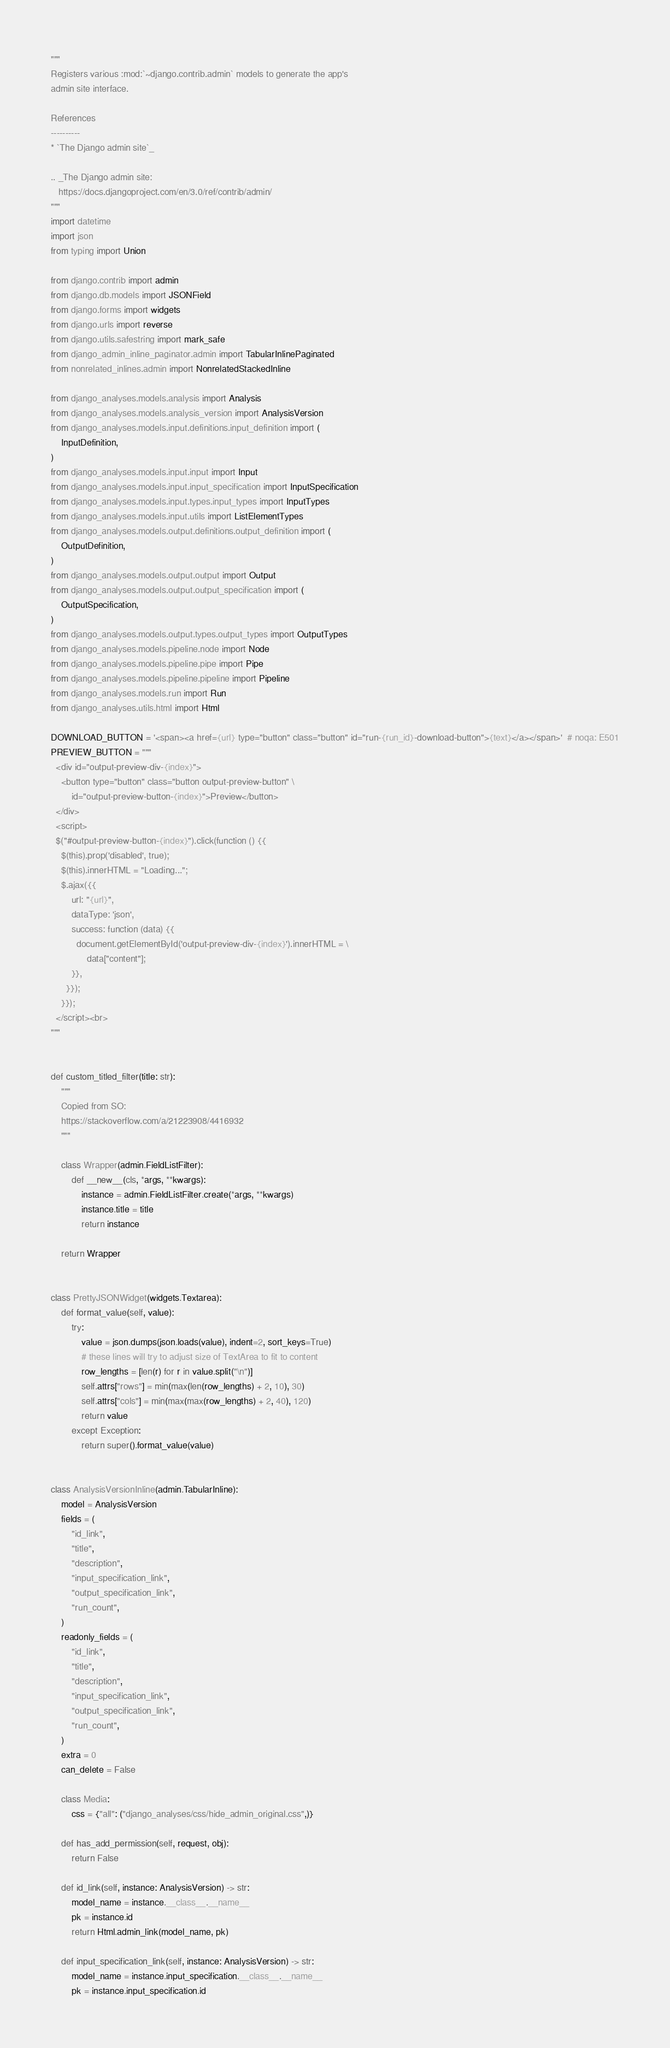<code> <loc_0><loc_0><loc_500><loc_500><_Python_>"""
Registers various :mod:`~django.contrib.admin` models to generate the app's
admin site interface.

References
----------
* `The Django admin site`_

.. _The Django admin site:
   https://docs.djangoproject.com/en/3.0/ref/contrib/admin/
"""
import datetime
import json
from typing import Union

from django.contrib import admin
from django.db.models import JSONField
from django.forms import widgets
from django.urls import reverse
from django.utils.safestring import mark_safe
from django_admin_inline_paginator.admin import TabularInlinePaginated
from nonrelated_inlines.admin import NonrelatedStackedInline

from django_analyses.models.analysis import Analysis
from django_analyses.models.analysis_version import AnalysisVersion
from django_analyses.models.input.definitions.input_definition import (
    InputDefinition,
)
from django_analyses.models.input.input import Input
from django_analyses.models.input.input_specification import InputSpecification
from django_analyses.models.input.types.input_types import InputTypes
from django_analyses.models.input.utils import ListElementTypes
from django_analyses.models.output.definitions.output_definition import (
    OutputDefinition,
)
from django_analyses.models.output.output import Output
from django_analyses.models.output.output_specification import (
    OutputSpecification,
)
from django_analyses.models.output.types.output_types import OutputTypes
from django_analyses.models.pipeline.node import Node
from django_analyses.models.pipeline.pipe import Pipe
from django_analyses.models.pipeline.pipeline import Pipeline
from django_analyses.models.run import Run
from django_analyses.utils.html import Html

DOWNLOAD_BUTTON = '<span><a href={url} type="button" class="button" id="run-{run_id}-download-button">{text}</a></span>'  # noqa: E501
PREVIEW_BUTTON = """
  <div id="output-preview-div-{index}">
    <button type="button" class="button output-preview-button" \
        id="output-preview-button-{index}">Preview</button>
  </div>
  <script>
  $("#output-preview-button-{index}").click(function () {{
    $(this).prop('disabled', true);
    $(this).innerHTML = "Loading...";
    $.ajax({{
        url: "{url}",
        dataType: 'json',
        success: function (data) {{
          document.getElementById('output-preview-div-{index}').innerHTML = \
              data["content"];
        }},
      }});
    }});
  </script><br>
"""


def custom_titled_filter(title: str):
    """
    Copied from SO:
    https://stackoverflow.com/a/21223908/4416932
    """

    class Wrapper(admin.FieldListFilter):
        def __new__(cls, *args, **kwargs):
            instance = admin.FieldListFilter.create(*args, **kwargs)
            instance.title = title
            return instance

    return Wrapper


class PrettyJSONWidget(widgets.Textarea):
    def format_value(self, value):
        try:
            value = json.dumps(json.loads(value), indent=2, sort_keys=True)
            # these lines will try to adjust size of TextArea to fit to content
            row_lengths = [len(r) for r in value.split("\n")]
            self.attrs["rows"] = min(max(len(row_lengths) + 2, 10), 30)
            self.attrs["cols"] = min(max(max(row_lengths) + 2, 40), 120)
            return value
        except Exception:
            return super().format_value(value)


class AnalysisVersionInline(admin.TabularInline):
    model = AnalysisVersion
    fields = (
        "id_link",
        "title",
        "description",
        "input_specification_link",
        "output_specification_link",
        "run_count",
    )
    readonly_fields = (
        "id_link",
        "title",
        "description",
        "input_specification_link",
        "output_specification_link",
        "run_count",
    )
    extra = 0
    can_delete = False

    class Media:
        css = {"all": ("django_analyses/css/hide_admin_original.css",)}

    def has_add_permission(self, request, obj):
        return False

    def id_link(self, instance: AnalysisVersion) -> str:
        model_name = instance.__class__.__name__
        pk = instance.id
        return Html.admin_link(model_name, pk)

    def input_specification_link(self, instance: AnalysisVersion) -> str:
        model_name = instance.input_specification.__class__.__name__
        pk = instance.input_specification.id</code> 